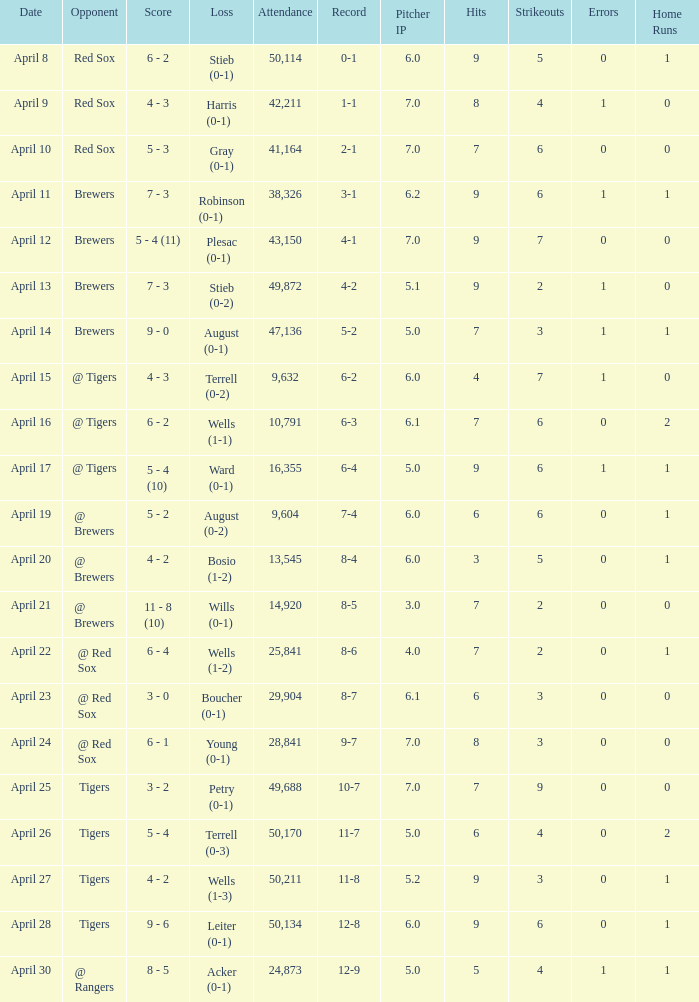What is the largest attendance that has tigers as the opponent and a loss of leiter (0-1)? 50134.0. 